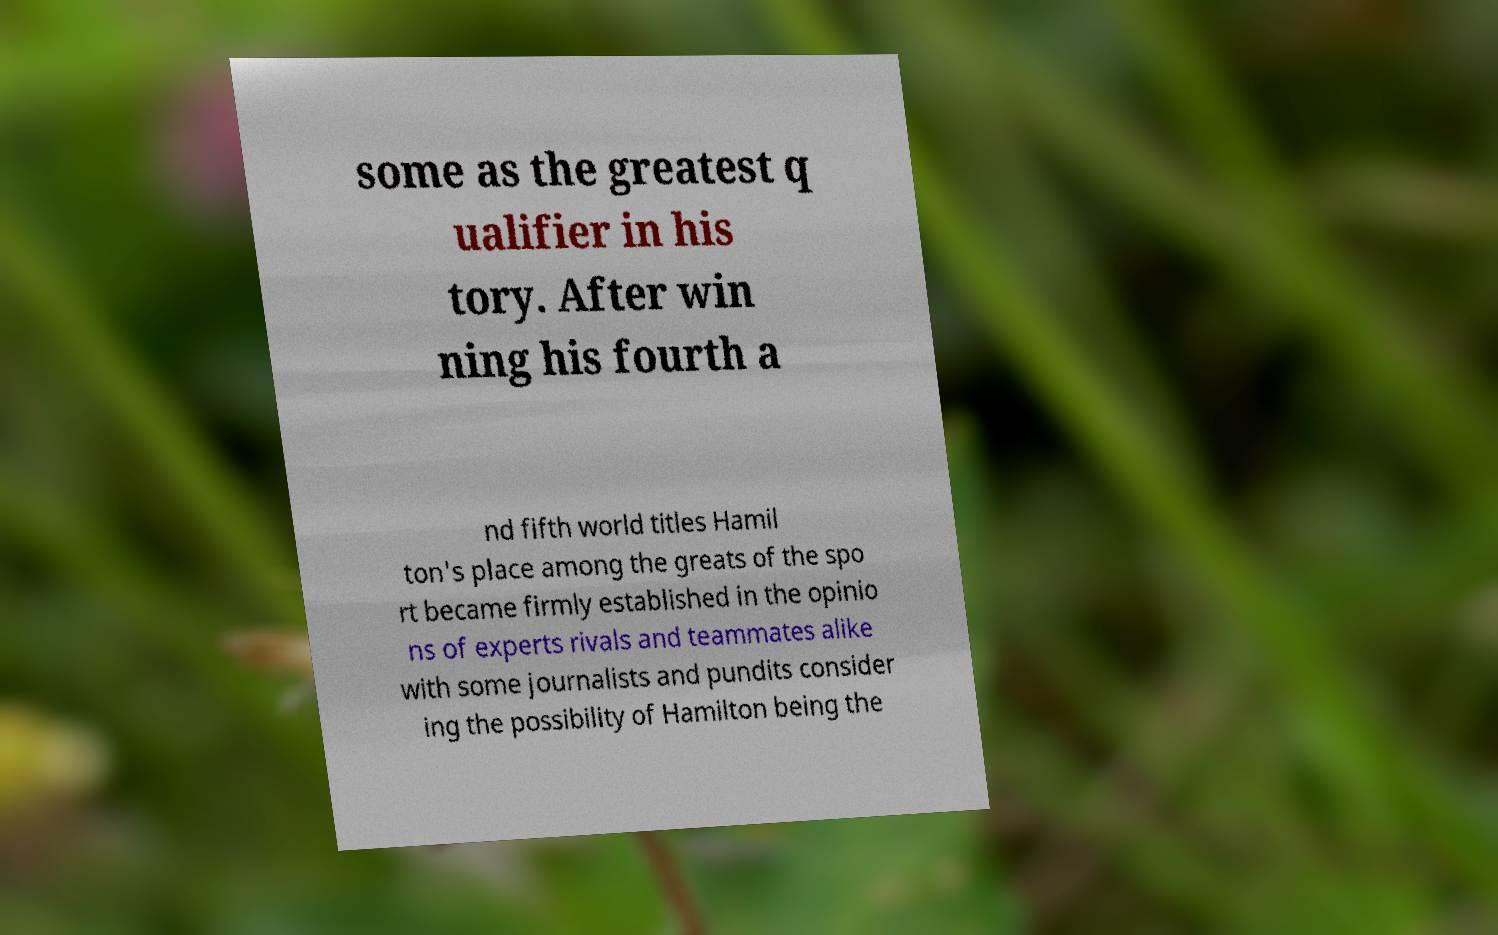Could you extract and type out the text from this image? some as the greatest q ualifier in his tory. After win ning his fourth a nd fifth world titles Hamil ton's place among the greats of the spo rt became firmly established in the opinio ns of experts rivals and teammates alike with some journalists and pundits consider ing the possibility of Hamilton being the 